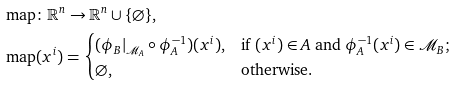Convert formula to latex. <formula><loc_0><loc_0><loc_500><loc_500>& \text {map} \colon \mathbb { R } ^ { n } \to \mathbb { R } ^ { n } \cup \{ \varnothing \} , \\ & \text {map} ( x ^ { i } ) = \begin{cases} ( \phi _ { B } | _ { \mathcal { M } _ { A } } \circ \phi _ { A } ^ { - 1 } ) ( x ^ { i } ) , & \text {if $(x^{i}) \in A$ and $\phi_{A}^{-1} (x^{i}) \in \mathcal{M}_{B}$;} \\ \varnothing , & \text {otherwise.} \end{cases}</formula> 